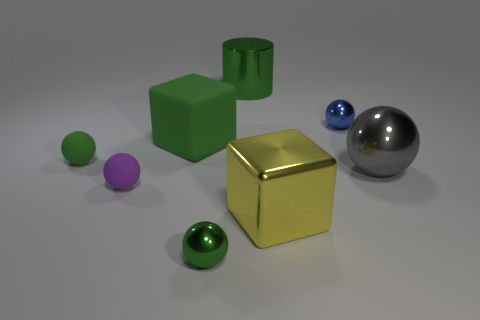Add 1 big cyan rubber objects. How many objects exist? 9 Subtract 4 spheres. How many spheres are left? 1 Subtract all green matte spheres. How many spheres are left? 4 Subtract all large rubber objects. Subtract all green cubes. How many objects are left? 6 Add 3 big green matte objects. How many big green matte objects are left? 4 Add 4 big cylinders. How many big cylinders exist? 5 Subtract all yellow cubes. How many cubes are left? 1 Subtract 0 red cylinders. How many objects are left? 8 Subtract all balls. How many objects are left? 3 Subtract all blue cylinders. Subtract all blue balls. How many cylinders are left? 1 